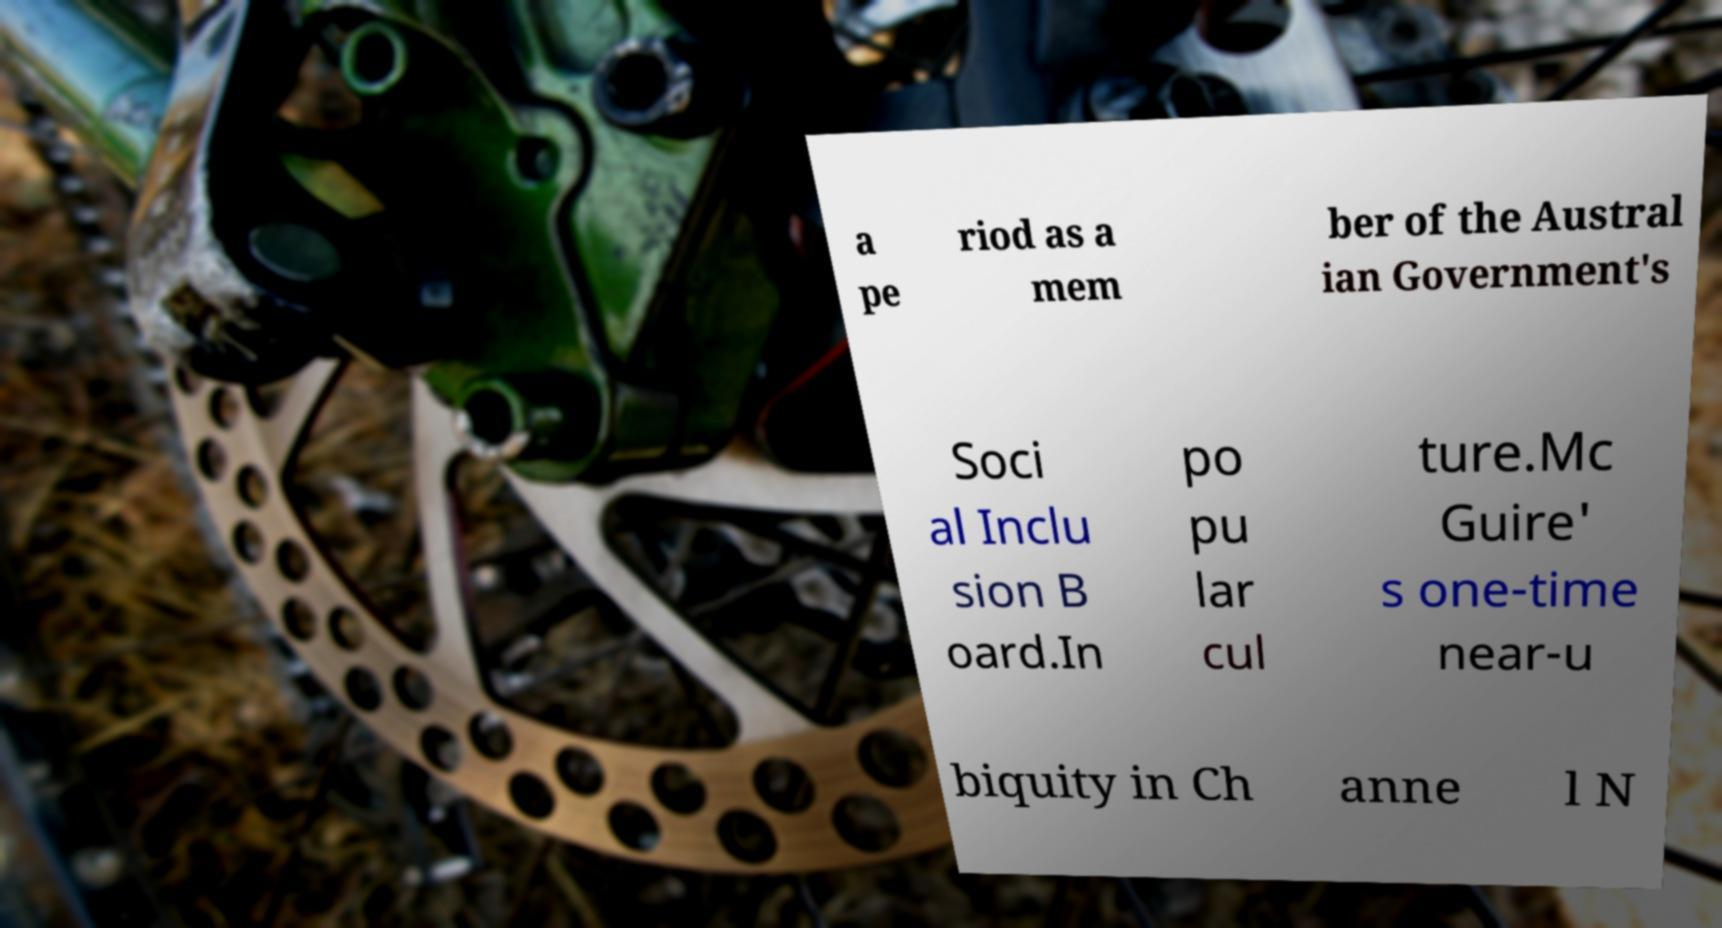Please identify and transcribe the text found in this image. a pe riod as a mem ber of the Austral ian Government's Soci al Inclu sion B oard.In po pu lar cul ture.Mc Guire' s one-time near-u biquity in Ch anne l N 